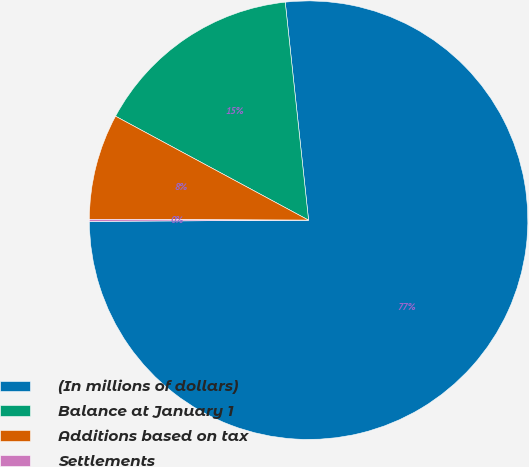Convert chart. <chart><loc_0><loc_0><loc_500><loc_500><pie_chart><fcel>(In millions of dollars)<fcel>Balance at January 1<fcel>Additions based on tax<fcel>Settlements<nl><fcel>76.61%<fcel>15.44%<fcel>7.8%<fcel>0.15%<nl></chart> 